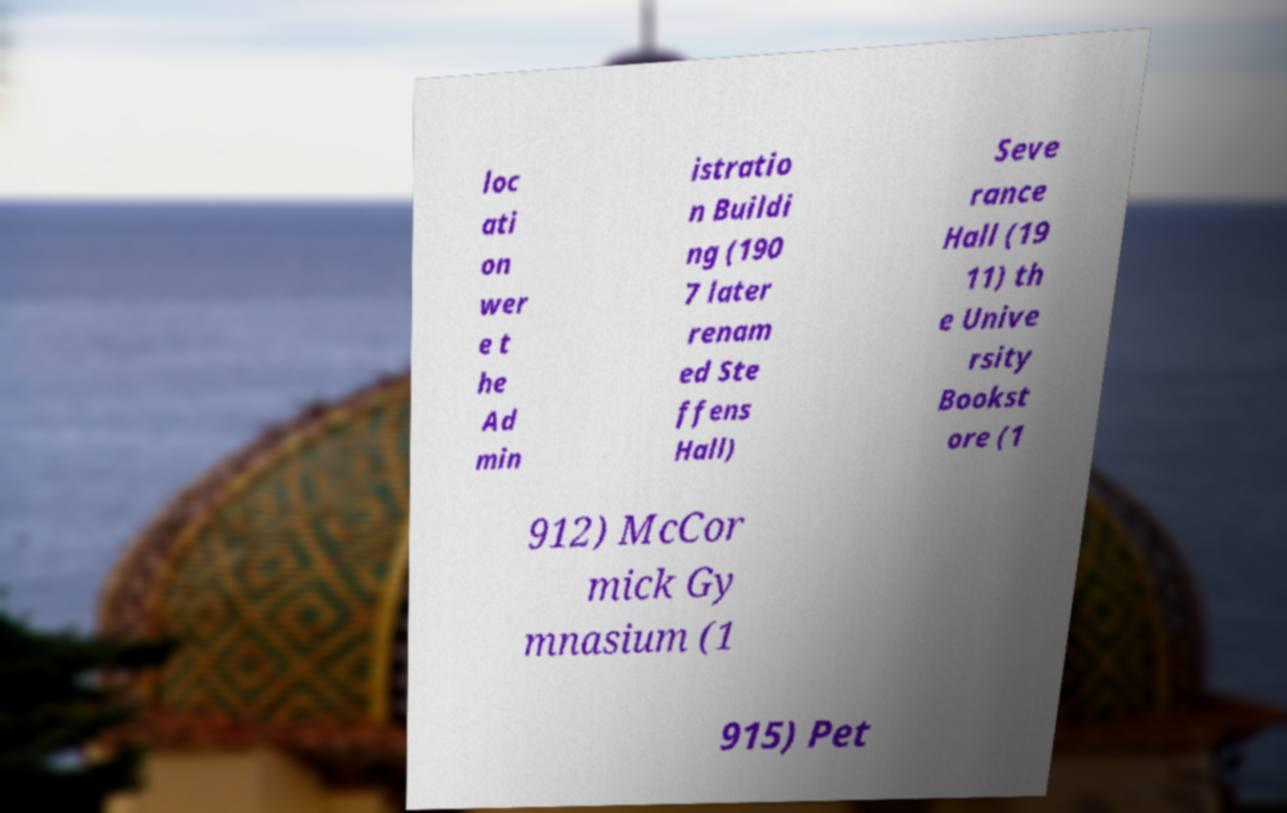What messages or text are displayed in this image? I need them in a readable, typed format. loc ati on wer e t he Ad min istratio n Buildi ng (190 7 later renam ed Ste ffens Hall) Seve rance Hall (19 11) th e Unive rsity Bookst ore (1 912) McCor mick Gy mnasium (1 915) Pet 